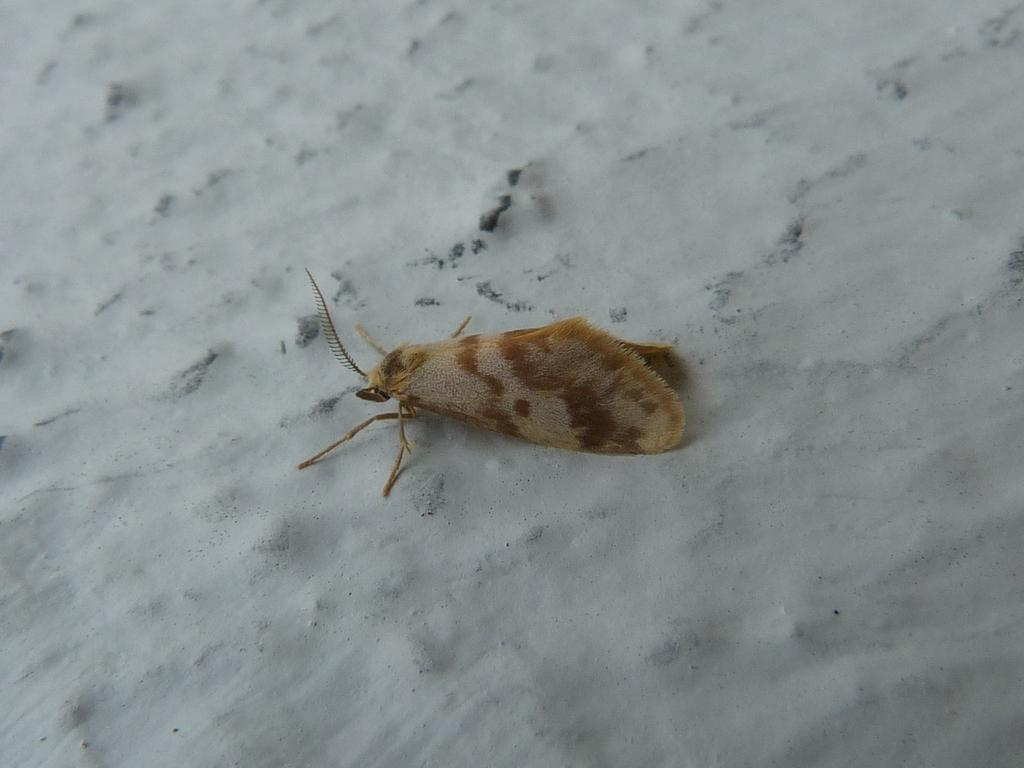What type of creature can be seen in the image? There is an insect in the image. Where is the insect located? The insect is on a rock surface. How many babies are present in the image? There are no babies present in the image; it features an insect on a rock surface. What type of drink is being served in the image? There is no drink present in the image, as it only features an insect on a rock surface. 